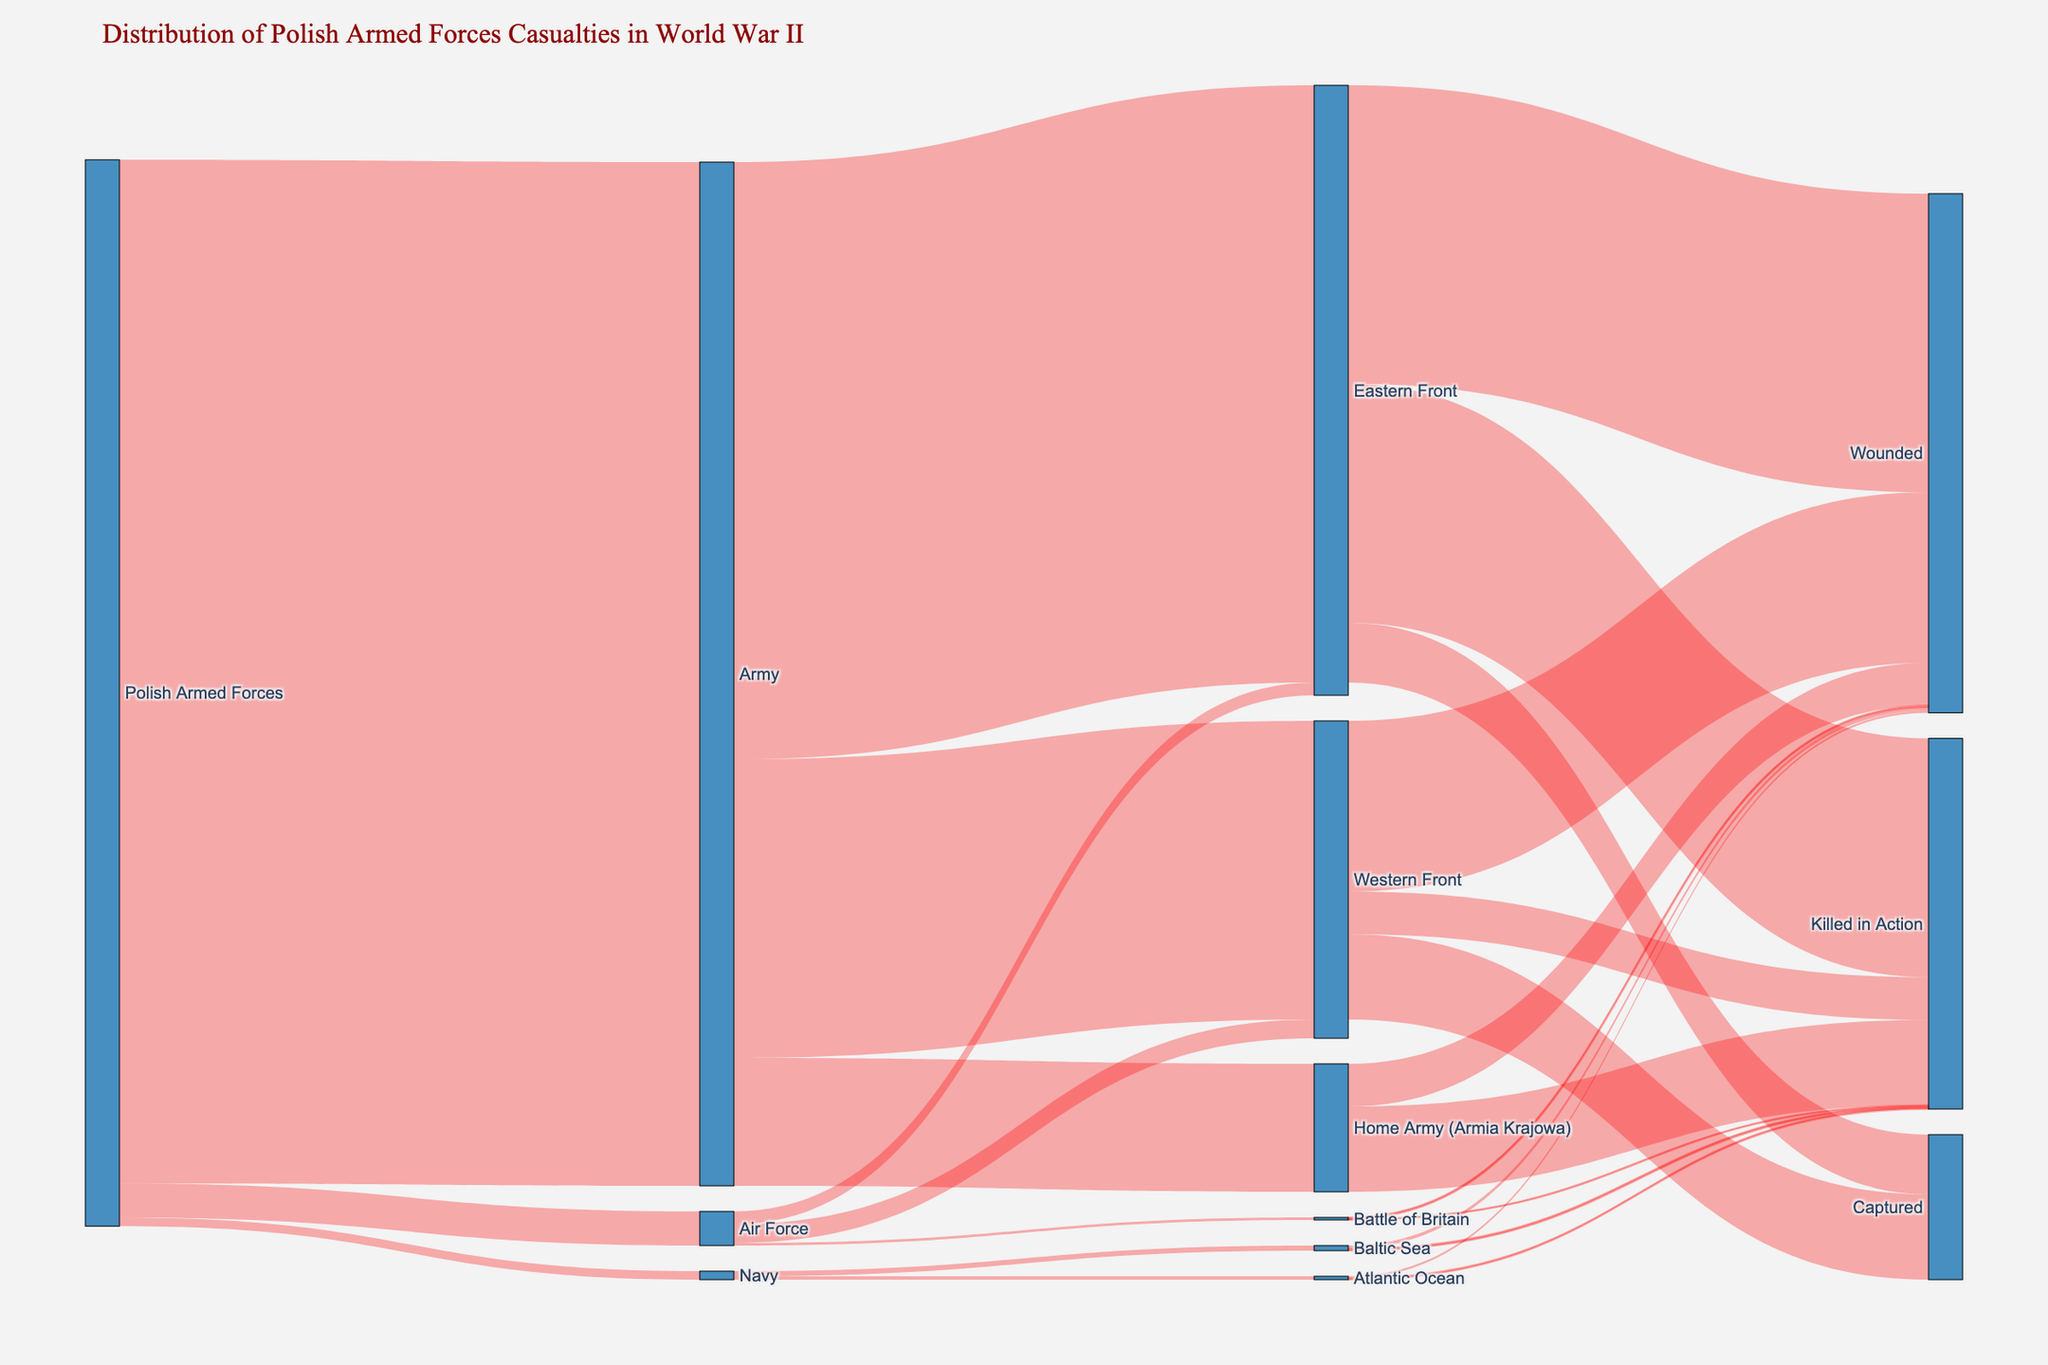What is the title of the Sankey diagram? The title can be found at the top of the figure in a different font and color. The title summarizes the content of the Sankey diagram.
Answer: Distribution of Polish Armed Forces Casualties in World War II How many casualties were in the Polish Army on the Eastern Front? Locate the flow from the "Army" to the "Eastern Front" and then look at the value associated with this flow.
Answer: 700,000 Which branch of the Polish Armed Forces had the smallest number of casualties? Compare the values flowing out from "Polish Armed Forces" towards each branch (Army, Air Force, Navy). The branch with the smallest value is the answer.
Answer: Navy How many total casualties were among the Polish Armed Forces during World War II? Sum the values flowing out from "Polish Armed Forces" to all branches (Army, Air Force, Navy).
Answer: 1,250,000 How many casualties did the Polish Air Force suffer in the Battle of Britain? Locate the flow from the "Air Force" to "Battle of Britain" and check the value associated with this flow.
Answer: 3,000 What is the total number of casualties faced by the Home Army (Armia Krajowa)? Sum the values flowing from "Home Army (Armia Krajowa)" to both "Killed in Action" and "Wounded".
Answer: 150,000 How many more casualties were killed in action on the Eastern Front compared to the Western Front? Locate and compare the values for "Killed in Action" on both fronts. Subtract the Western Front value from the Eastern Front value.
Answer: 230,000 Which theater of war had the highest number of wounded casualties? Compare the values for "Wounded" across all theaters (Eastern Front, Western Front, Home Army, Battle of Britain, Baltic Sea, Atlantic Ocean). The theater with the highest value is the answer.
Answer: Eastern Front Of the branches of the Polish Armed Forces, which one contributed the most to the Western Front? Compare the flows from each branch (Army, Air Force) to the "Western Front". Identify the branch with the largest value.
Answer: Army How many total casualties were captured across all theaters? Sum the values of "Captured" across all theaters (Eastern Front, Western Front).
Answer: 170,000 